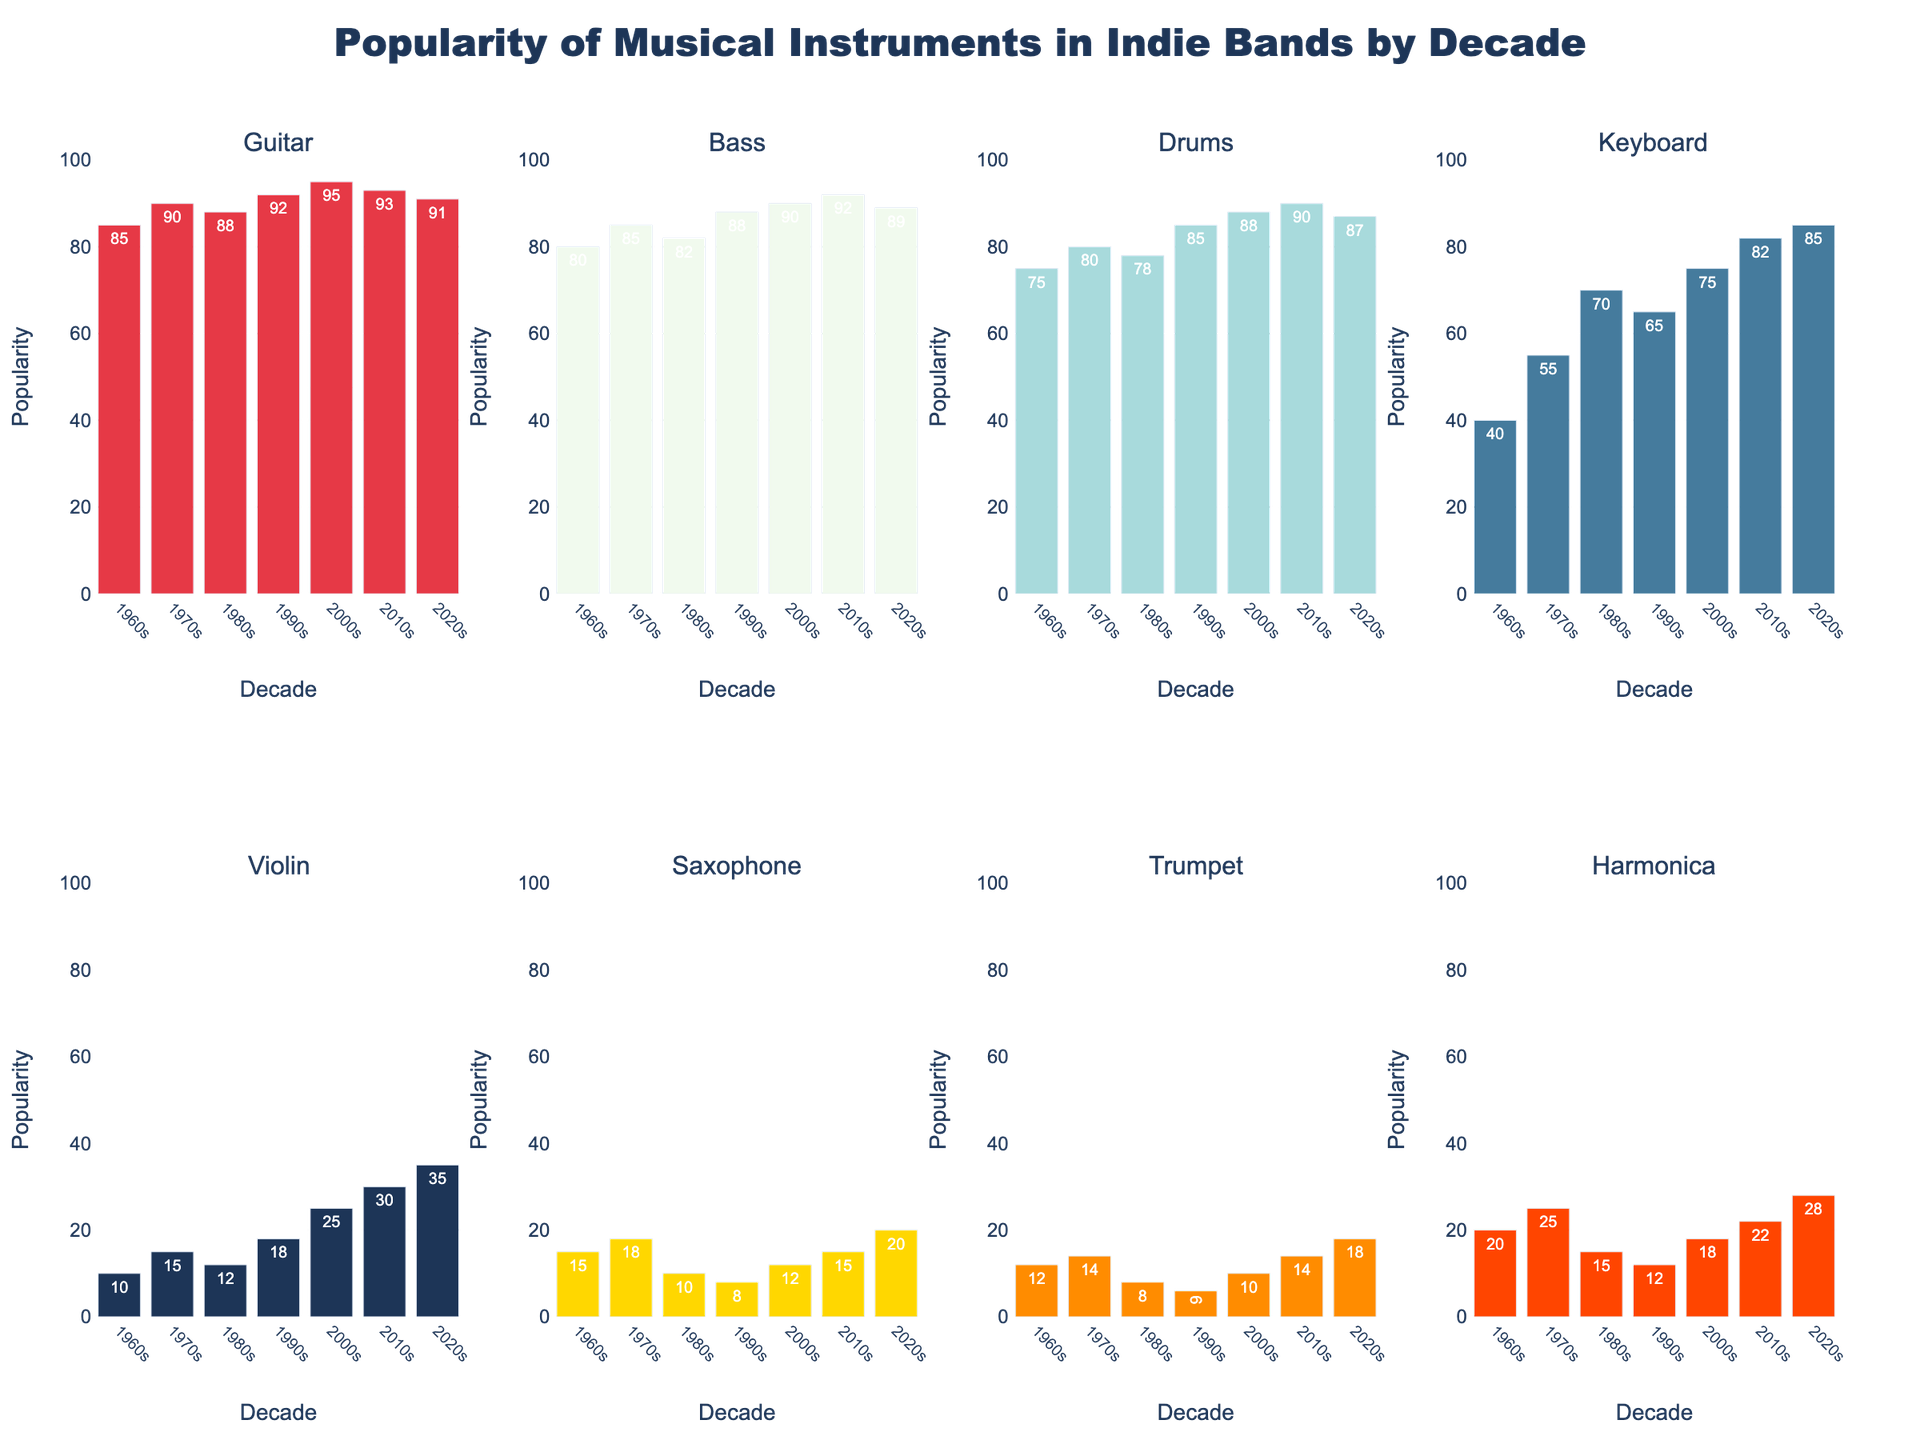Which decade had the highest popularity of the Violin? In the 2020s, the bar for the Violin is the tallest compared to the other decades. This indicates that the highest popularity of the Violin occurred in the 2020s.
Answer: 2020s How does the popularity of the Guitar in the 2010s compare to the 2020s? The height of the bar for the Guitar in the 2010s is at 93, while in the 2020s, it is at 91. Hence, the Guitar popularity decreased slightly in the 2020s compared to the 2010s.
Answer: Decreased What is the combined popularity of Drums and Bass in the 1990s? The popularity of Drums in the 1990s is 85, and the Bass is 88. Summing these values gives 85 + 88 = 173.
Answer: 173 Which instrument saw the most significant increase in popularity from the 1960s to the 2020s? Compare the differences from the 1960s to the 2020s for all instruments as follows: Guitar (91-85=6), Bass (89-80=9), Drums (87-75=12), Keyboard (85-40=45), Violin (35-10=25), Saxophone (20-15=5), Trumpet (18-12=6), Harmonica (28-20=8). The Keyboard saw the most significant increase of 45.
Answer: Keyboard In which decade did the Harmonica have the least popularity? The smallest bar for the Harmonica is in the 1990s, where its popularity is 12.
Answer: 1990s Which instrument has more consistent popularity across decades: the Guitar or the Trumpet? Both the Guitar and Trumpet have stable heights, but visually, the Guitar bars fluctuate minimally between 85 and 95, while the Trumpet bars range between 6 to 18. This indicates the Guitar has more consistent popularity across decades.
Answer: Guitar Calculate the average popularity of the Keyboard over all decades. Sum the Keyboard popularity values (40 + 55 + 70 + 65 + 75 + 82 + 85 = 472) and divide by the number of decades (472 / 7 = 67.43, rounded to two decimal places).
Answer: 67.43 What is the difference in popularity between the most and least popular instrument in the 1970s? In the 1970s, the Guitar's popularity is the highest at 90, and the Trumpet is the least at 14. The difference is 90 - 14 = 76.
Answer: 76 Which decade saw the biggest drop in popularity for the Saxophone compared to the previous decade? Comparing each decade: 1960s to 1970s (18-15=3), 1970s to 1980s (18-10=8), 1980s to 1990s (10-8=2), 1990s to 2000s (12-8=4). The 1970s to the 1980s saw the biggest drop of 8.
Answer: 1980s 